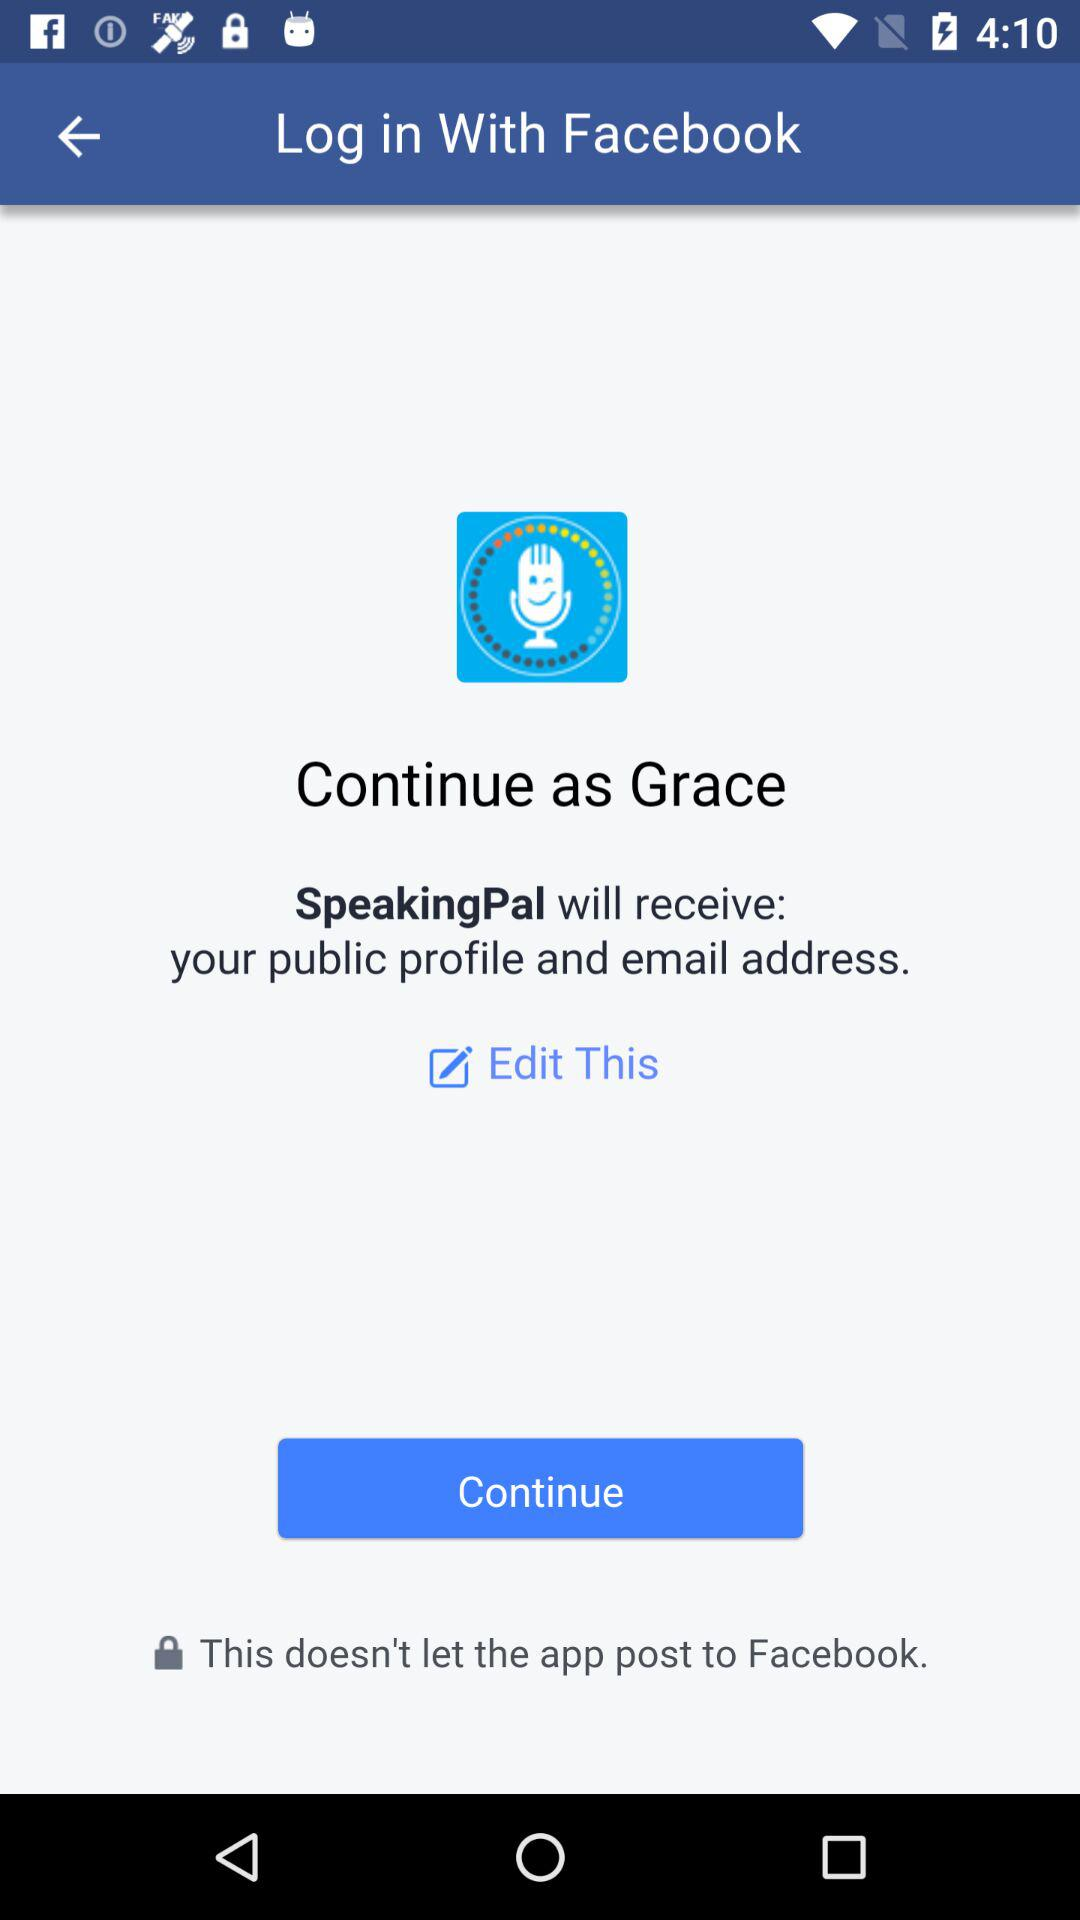What is the username? The username is Grace. 